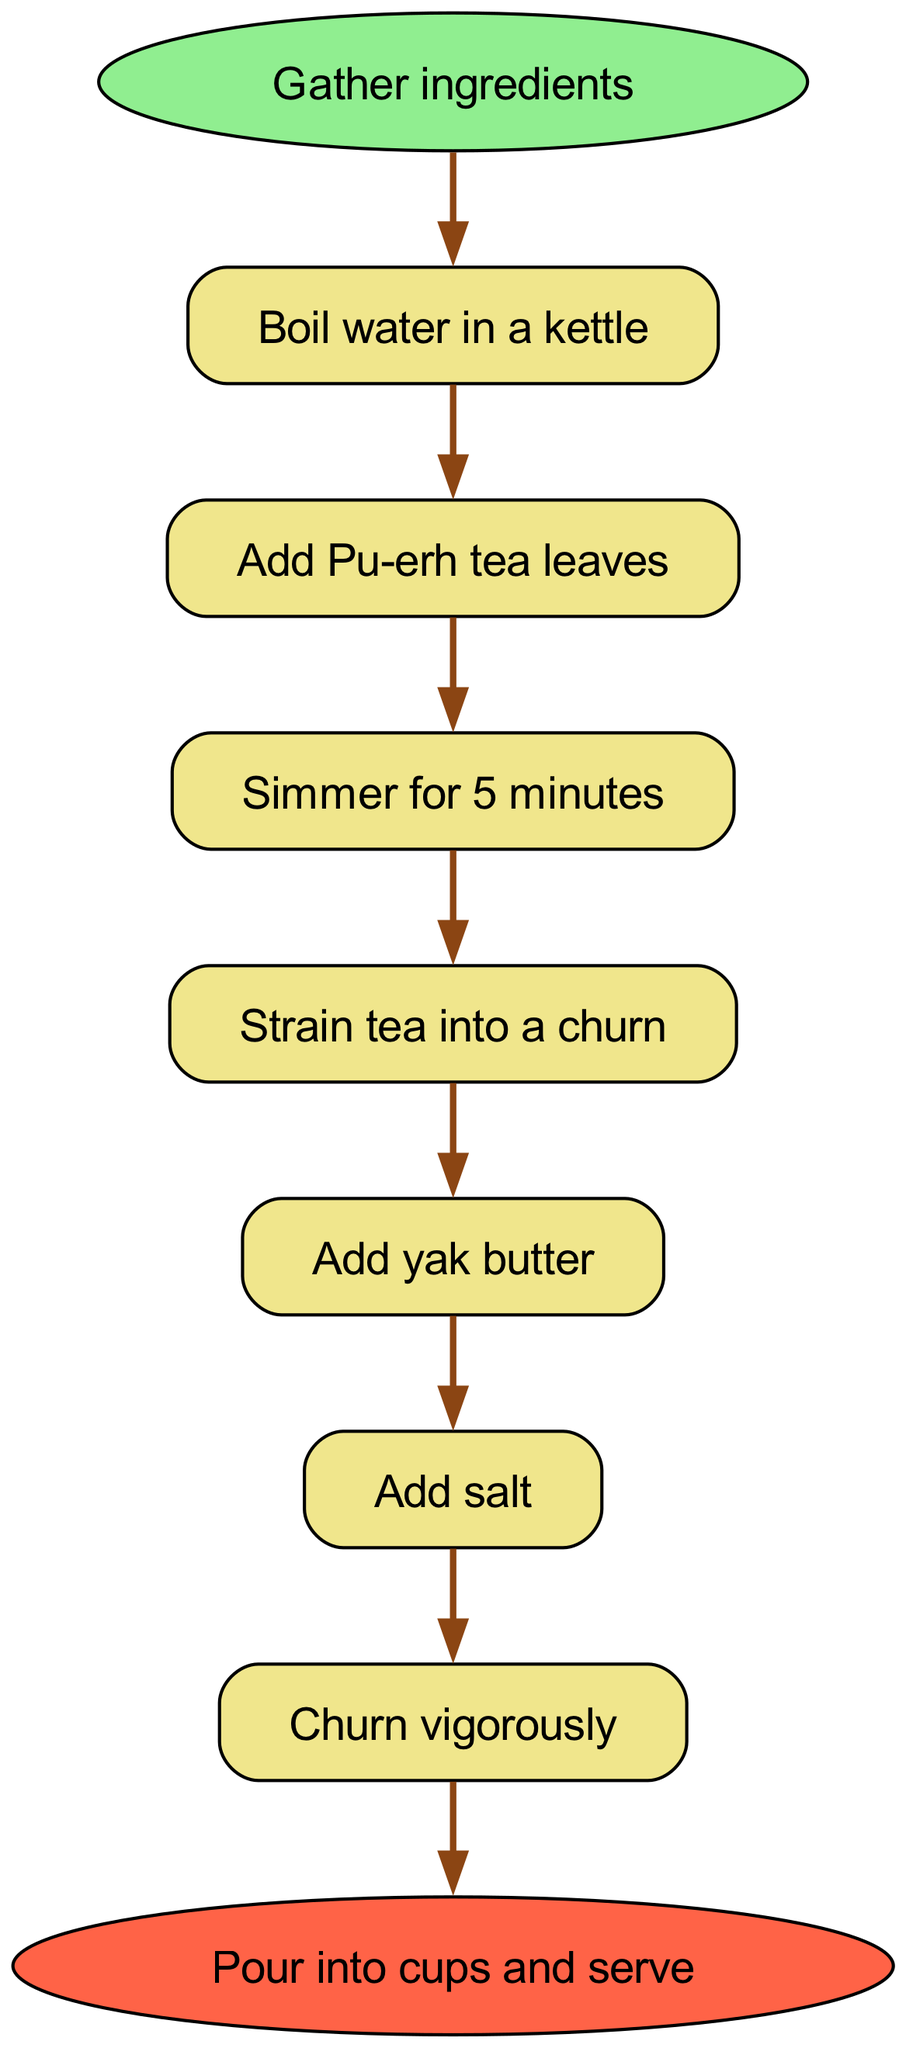What is the first step in preparing butter tea? The diagram indicates that the first step is "Boil water in a kettle". This is represented as the first node after the start of the flow.
Answer: Boil water in a kettle How many total steps are there in the preparation process? By counting the nodes labeled with steps, one can see that there are seven individual steps listed, not including the start and end nodes.
Answer: 7 What ingredient is added after the tea leaves? Following the "Add Pu-erh tea leaves" step, the next action in the sequence is "Simmer for 5 minutes", identifying that the immediate next step does not refer to an ingredient. However, the next ingredient added after the tea is "Add yak butter".
Answer: Add yak butter Which step comes before the final step? The final step is "Pour into cups and serve", which directly follows "Churn vigorously". Therefore, the step prior to the end node is "Churn vigorously".
Answer: Churn vigorously What is the relationship between straining the tea and adding salt? The diagram shows that "Strain tea into a churn" occurs before "Add salt", indicating a sequential relationship where straining the tea is a prerequisite to adding salt.
Answer: Sequential relationship How many edges connect the nodes? Each step in the process has a connecting edge leading to the next step, culminating in a total of eight edges: seven for the steps and one for connecting to the end.
Answer: 8 What ingredient is mentioned in step 6? The sixth step in the flow chart explicitly states "Add salt", which is a crucial ingredient for the butter tea preparation.
Answer: Add salt What does the end node signify? The end node "Pour into cups and serve" indicates the conclusion of the butter tea preparation process, representing what to do after completing all prior steps.
Answer: Conclusion of the preparation process 